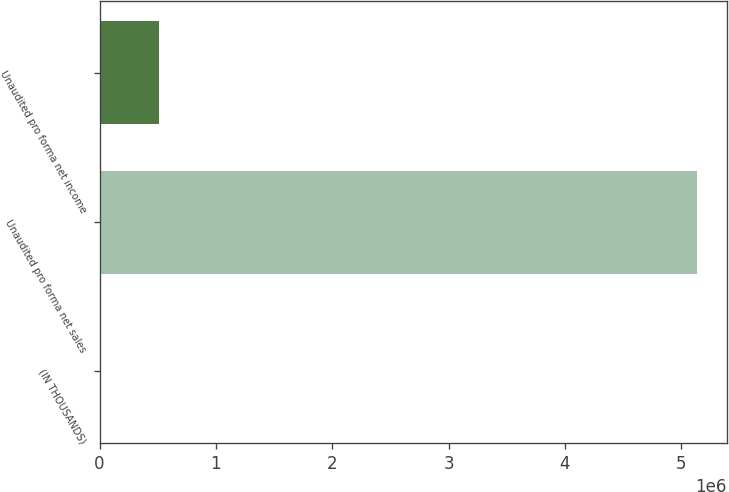<chart> <loc_0><loc_0><loc_500><loc_500><bar_chart><fcel>(IN THOUSANDS)<fcel>Unaudited pro forma net sales<fcel>Unaudited pro forma net income<nl><fcel>2018<fcel>5.13591e+06<fcel>515407<nl></chart> 